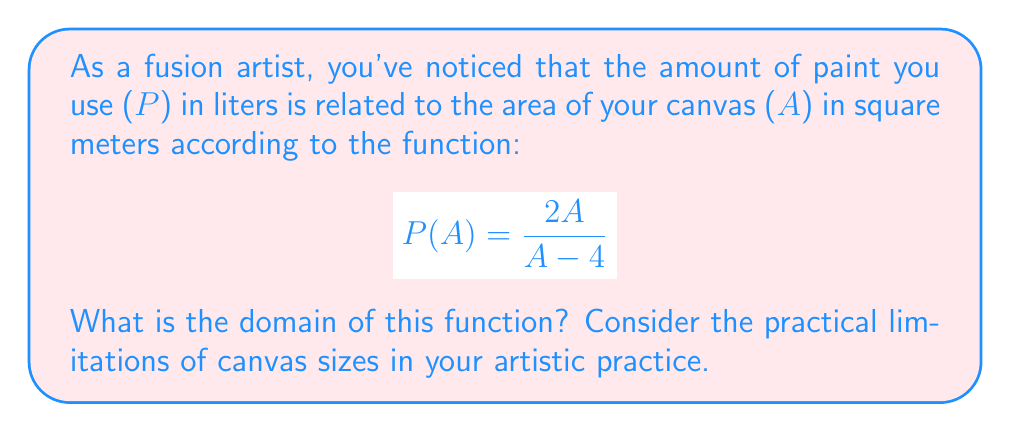Give your solution to this math problem. Let's approach this step-by-step:

1) The domain of a rational function includes all real numbers except those that make the denominator equal to zero.

2) In this case, the denominator is $A - 4$. We need to find when this equals zero:

   $$A - 4 = 0$$
   $$A = 4$$

3) This means that when $A = 4$, the function is undefined.

4) Mathematically, the domain would be all real numbers except 4: $\mathbb{R} \setminus \{4\}$

5) However, as artists, we need to consider practical limitations:
   - Canvas size can't be negative, so $A > 0$
   - The function implies that as $A$ approaches 4 from either side, $P(A)$ approaches infinity, which isn't realistic for paint usage

6) Therefore, we should consider two intervals:
   - $0 < A < 4$: This represents small to medium-sized canvases
   - $A > 4$: This represents medium to large-sized canvases

7) Combining these practical considerations with the mathematical constraint, our domain becomes:

   $$(0, 4) \cup (4, \infty)$$

This domain represents all positive canvas sizes except for exactly 4 square meters.
Answer: $(0, 4) \cup (4, \infty)$ 